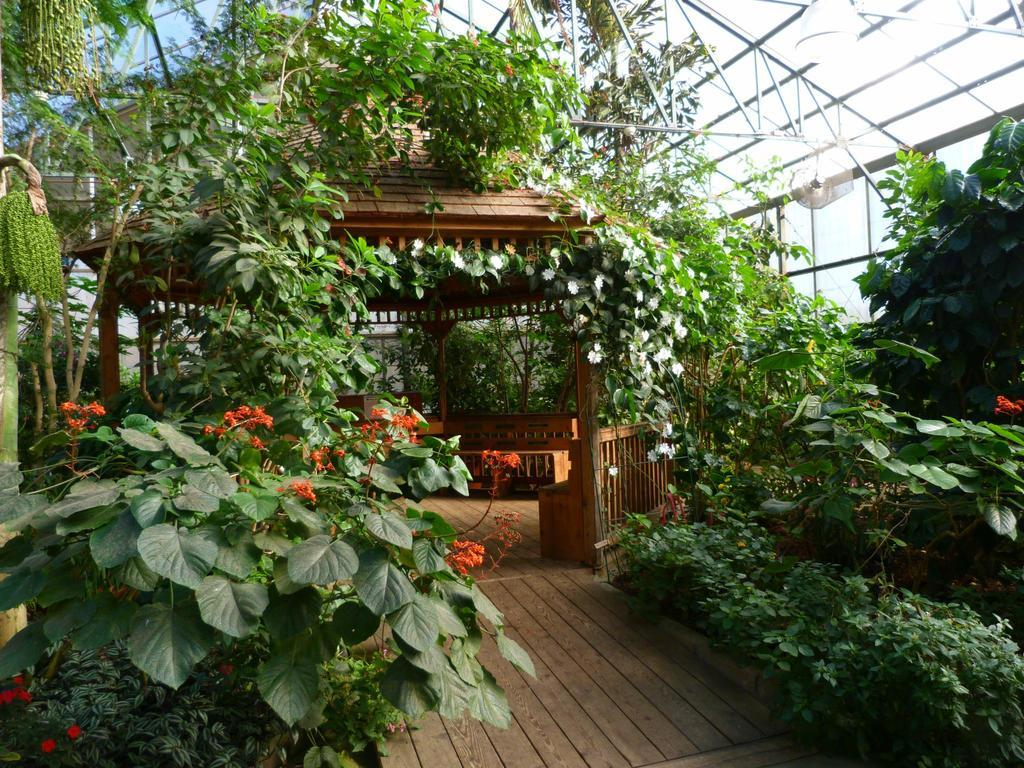What type of living organisms can be seen in the image? Plants can be seen in the image. What structure is located behind the plants? There is an arch behind the plants. What part of a building can be seen at the top of the image? A roof is visible at the top of the image. How many clams are sitting on the roof in the image? There are no clams present in the image; it features plants and an arch with a roof visible at the top. 